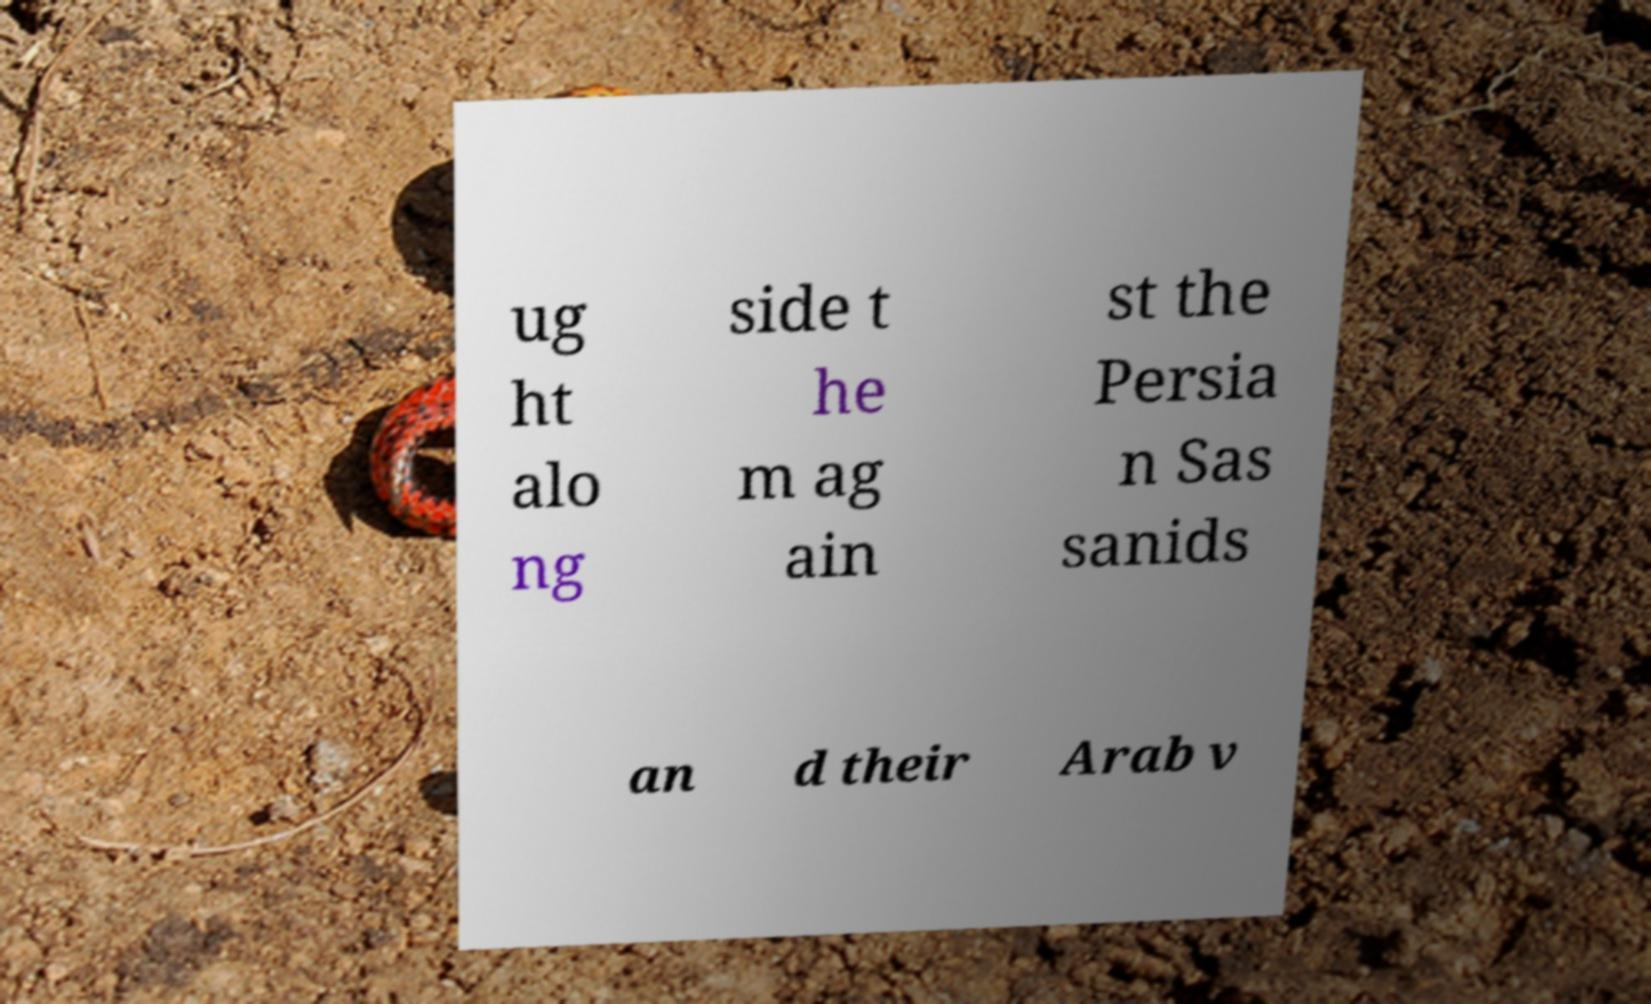What messages or text are displayed in this image? I need them in a readable, typed format. ug ht alo ng side t he m ag ain st the Persia n Sas sanids an d their Arab v 